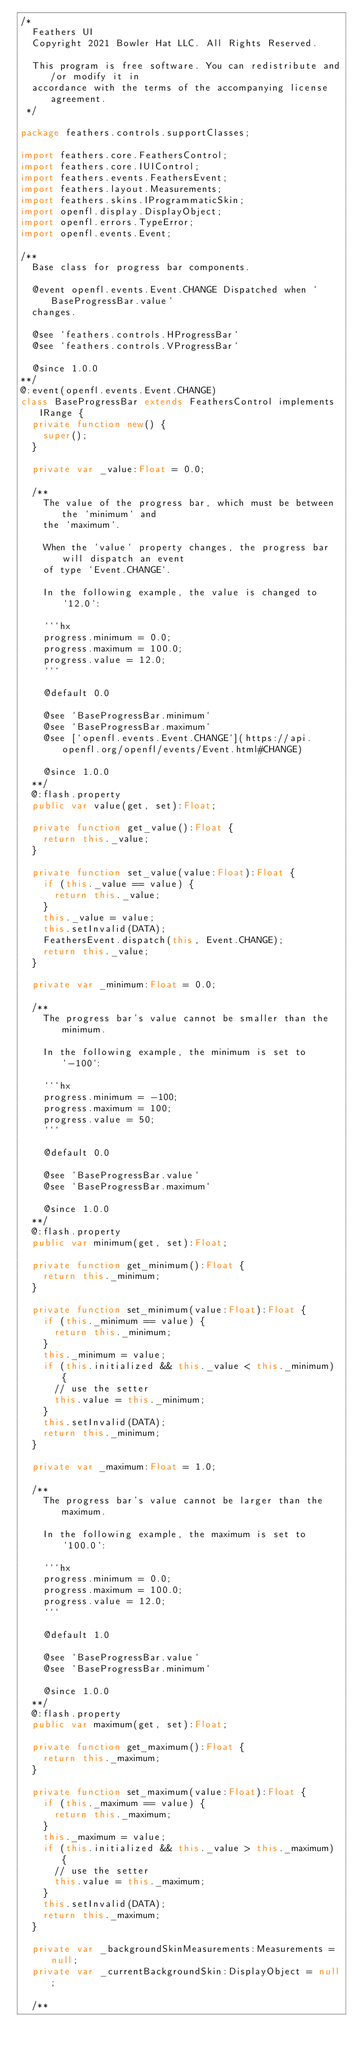<code> <loc_0><loc_0><loc_500><loc_500><_Haxe_>/*
	Feathers UI
	Copyright 2021 Bowler Hat LLC. All Rights Reserved.

	This program is free software. You can redistribute and/or modify it in
	accordance with the terms of the accompanying license agreement.
 */

package feathers.controls.supportClasses;

import feathers.core.FeathersControl;
import feathers.core.IUIControl;
import feathers.events.FeathersEvent;
import feathers.layout.Measurements;
import feathers.skins.IProgrammaticSkin;
import openfl.display.DisplayObject;
import openfl.errors.TypeError;
import openfl.events.Event;

/**
	Base class for progress bar components.

	@event openfl.events.Event.CHANGE Dispatched when `BaseProgressBar.value`
	changes.

	@see `feathers.controls.HProgressBar`
	@see `feathers.controls.VProgressBar`

	@since 1.0.0
**/
@:event(openfl.events.Event.CHANGE)
class BaseProgressBar extends FeathersControl implements IRange {
	private function new() {
		super();
	}

	private var _value:Float = 0.0;

	/**
		The value of the progress bar, which must be between the `minimum` and
		the `maximum`.

		When the `value` property changes, the progress bar will dispatch an event
		of type `Event.CHANGE`.

		In the following example, the value is changed to `12.0`:

		```hx
		progress.minimum = 0.0;
		progress.maximum = 100.0;
		progress.value = 12.0;
		```

		@default 0.0

		@see `BaseProgressBar.minimum`
		@see `BaseProgressBar.maximum`
		@see [`openfl.events.Event.CHANGE`](https://api.openfl.org/openfl/events/Event.html#CHANGE)

		@since 1.0.0
	**/
	@:flash.property
	public var value(get, set):Float;

	private function get_value():Float {
		return this._value;
	}

	private function set_value(value:Float):Float {
		if (this._value == value) {
			return this._value;
		}
		this._value = value;
		this.setInvalid(DATA);
		FeathersEvent.dispatch(this, Event.CHANGE);
		return this._value;
	}

	private var _minimum:Float = 0.0;

	/**
		The progress bar's value cannot be smaller than the minimum.

		In the following example, the minimum is set to `-100`:

		```hx
		progress.minimum = -100;
		progress.maximum = 100;
		progress.value = 50;
		```

		@default 0.0

		@see `BaseProgressBar.value`
		@see `BaseProgressBar.maximum`

		@since 1.0.0
	**/
	@:flash.property
	public var minimum(get, set):Float;

	private function get_minimum():Float {
		return this._minimum;
	}

	private function set_minimum(value:Float):Float {
		if (this._minimum == value) {
			return this._minimum;
		}
		this._minimum = value;
		if (this.initialized && this._value < this._minimum) {
			// use the setter
			this.value = this._minimum;
		}
		this.setInvalid(DATA);
		return this._minimum;
	}

	private var _maximum:Float = 1.0;

	/**
		The progress bar's value cannot be larger than the maximum.

		In the following example, the maximum is set to `100.0`:

		```hx
		progress.minimum = 0.0;
		progress.maximum = 100.0;
		progress.value = 12.0;
		```

		@default 1.0

		@see `BaseProgressBar.value`
		@see `BaseProgressBar.minimum`

		@since 1.0.0
	**/
	@:flash.property
	public var maximum(get, set):Float;

	private function get_maximum():Float {
		return this._maximum;
	}

	private function set_maximum(value:Float):Float {
		if (this._maximum == value) {
			return this._maximum;
		}
		this._maximum = value;
		if (this.initialized && this._value > this._maximum) {
			// use the setter
			this.value = this._maximum;
		}
		this.setInvalid(DATA);
		return this._maximum;
	}

	private var _backgroundSkinMeasurements:Measurements = null;
	private var _currentBackgroundSkin:DisplayObject = null;

	/**</code> 